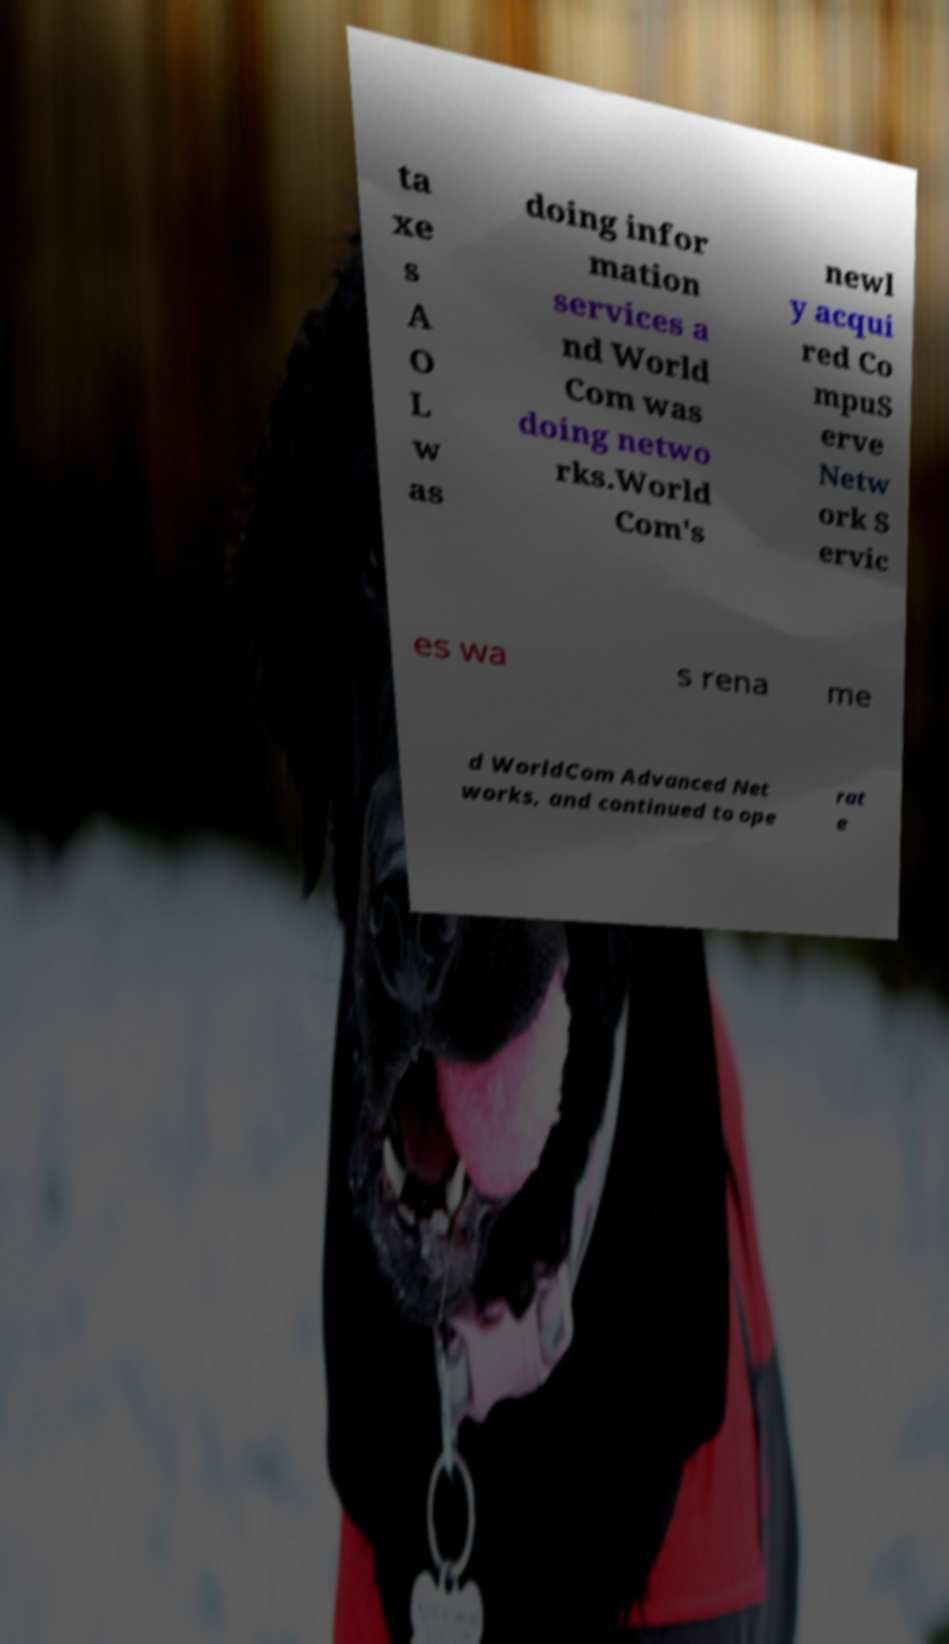Could you assist in decoding the text presented in this image and type it out clearly? ta xe s A O L w as doing infor mation services a nd World Com was doing netwo rks.World Com's newl y acqui red Co mpuS erve Netw ork S ervic es wa s rena me d WorldCom Advanced Net works, and continued to ope rat e 